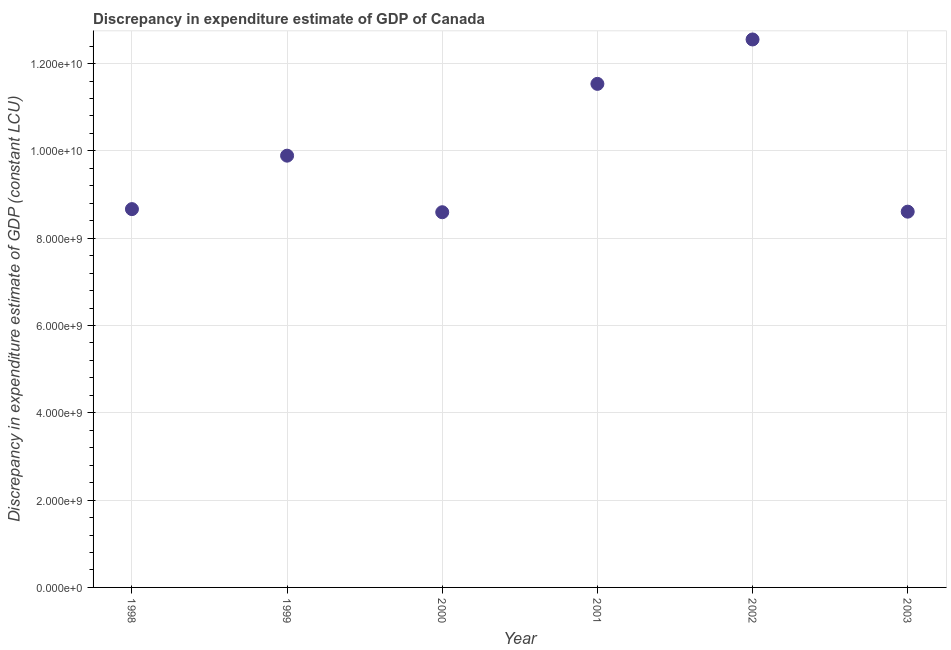What is the discrepancy in expenditure estimate of gdp in 2000?
Your response must be concise. 8.60e+09. Across all years, what is the maximum discrepancy in expenditure estimate of gdp?
Your response must be concise. 1.26e+1. Across all years, what is the minimum discrepancy in expenditure estimate of gdp?
Provide a short and direct response. 8.60e+09. In which year was the discrepancy in expenditure estimate of gdp minimum?
Your answer should be very brief. 2000. What is the sum of the discrepancy in expenditure estimate of gdp?
Your answer should be compact. 5.99e+1. What is the difference between the discrepancy in expenditure estimate of gdp in 1998 and 2002?
Offer a terse response. -3.89e+09. What is the average discrepancy in expenditure estimate of gdp per year?
Give a very brief answer. 9.98e+09. What is the median discrepancy in expenditure estimate of gdp?
Your answer should be compact. 9.28e+09. In how many years, is the discrepancy in expenditure estimate of gdp greater than 7600000000 LCU?
Your answer should be compact. 6. What is the ratio of the discrepancy in expenditure estimate of gdp in 1998 to that in 2002?
Your response must be concise. 0.69. Is the discrepancy in expenditure estimate of gdp in 1999 less than that in 2000?
Your answer should be compact. No. What is the difference between the highest and the second highest discrepancy in expenditure estimate of gdp?
Your answer should be compact. 1.02e+09. What is the difference between the highest and the lowest discrepancy in expenditure estimate of gdp?
Provide a succinct answer. 3.96e+09. In how many years, is the discrepancy in expenditure estimate of gdp greater than the average discrepancy in expenditure estimate of gdp taken over all years?
Keep it short and to the point. 2. Does the discrepancy in expenditure estimate of gdp monotonically increase over the years?
Offer a terse response. No. How many dotlines are there?
Make the answer very short. 1. How many years are there in the graph?
Provide a succinct answer. 6. What is the difference between two consecutive major ticks on the Y-axis?
Make the answer very short. 2.00e+09. What is the title of the graph?
Your response must be concise. Discrepancy in expenditure estimate of GDP of Canada. What is the label or title of the Y-axis?
Provide a short and direct response. Discrepancy in expenditure estimate of GDP (constant LCU). What is the Discrepancy in expenditure estimate of GDP (constant LCU) in 1998?
Give a very brief answer. 8.67e+09. What is the Discrepancy in expenditure estimate of GDP (constant LCU) in 1999?
Your answer should be compact. 9.89e+09. What is the Discrepancy in expenditure estimate of GDP (constant LCU) in 2000?
Provide a succinct answer. 8.60e+09. What is the Discrepancy in expenditure estimate of GDP (constant LCU) in 2001?
Provide a short and direct response. 1.15e+1. What is the Discrepancy in expenditure estimate of GDP (constant LCU) in 2002?
Offer a terse response. 1.26e+1. What is the Discrepancy in expenditure estimate of GDP (constant LCU) in 2003?
Make the answer very short. 8.61e+09. What is the difference between the Discrepancy in expenditure estimate of GDP (constant LCU) in 1998 and 1999?
Ensure brevity in your answer.  -1.22e+09. What is the difference between the Discrepancy in expenditure estimate of GDP (constant LCU) in 1998 and 2000?
Offer a terse response. 7.13e+07. What is the difference between the Discrepancy in expenditure estimate of GDP (constant LCU) in 1998 and 2001?
Ensure brevity in your answer.  -2.87e+09. What is the difference between the Discrepancy in expenditure estimate of GDP (constant LCU) in 1998 and 2002?
Provide a short and direct response. -3.89e+09. What is the difference between the Discrepancy in expenditure estimate of GDP (constant LCU) in 1998 and 2003?
Provide a succinct answer. 5.85e+07. What is the difference between the Discrepancy in expenditure estimate of GDP (constant LCU) in 1999 and 2000?
Your response must be concise. 1.30e+09. What is the difference between the Discrepancy in expenditure estimate of GDP (constant LCU) in 1999 and 2001?
Ensure brevity in your answer.  -1.64e+09. What is the difference between the Discrepancy in expenditure estimate of GDP (constant LCU) in 1999 and 2002?
Your response must be concise. -2.66e+09. What is the difference between the Discrepancy in expenditure estimate of GDP (constant LCU) in 1999 and 2003?
Give a very brief answer. 1.28e+09. What is the difference between the Discrepancy in expenditure estimate of GDP (constant LCU) in 2000 and 2001?
Make the answer very short. -2.94e+09. What is the difference between the Discrepancy in expenditure estimate of GDP (constant LCU) in 2000 and 2002?
Keep it short and to the point. -3.96e+09. What is the difference between the Discrepancy in expenditure estimate of GDP (constant LCU) in 2000 and 2003?
Your response must be concise. -1.29e+07. What is the difference between the Discrepancy in expenditure estimate of GDP (constant LCU) in 2001 and 2002?
Make the answer very short. -1.02e+09. What is the difference between the Discrepancy in expenditure estimate of GDP (constant LCU) in 2001 and 2003?
Your answer should be very brief. 2.93e+09. What is the difference between the Discrepancy in expenditure estimate of GDP (constant LCU) in 2002 and 2003?
Offer a terse response. 3.94e+09. What is the ratio of the Discrepancy in expenditure estimate of GDP (constant LCU) in 1998 to that in 1999?
Offer a very short reply. 0.88. What is the ratio of the Discrepancy in expenditure estimate of GDP (constant LCU) in 1998 to that in 2001?
Provide a short and direct response. 0.75. What is the ratio of the Discrepancy in expenditure estimate of GDP (constant LCU) in 1998 to that in 2002?
Your answer should be very brief. 0.69. What is the ratio of the Discrepancy in expenditure estimate of GDP (constant LCU) in 1999 to that in 2000?
Your response must be concise. 1.15. What is the ratio of the Discrepancy in expenditure estimate of GDP (constant LCU) in 1999 to that in 2001?
Provide a succinct answer. 0.86. What is the ratio of the Discrepancy in expenditure estimate of GDP (constant LCU) in 1999 to that in 2002?
Give a very brief answer. 0.79. What is the ratio of the Discrepancy in expenditure estimate of GDP (constant LCU) in 1999 to that in 2003?
Offer a terse response. 1.15. What is the ratio of the Discrepancy in expenditure estimate of GDP (constant LCU) in 2000 to that in 2001?
Offer a terse response. 0.74. What is the ratio of the Discrepancy in expenditure estimate of GDP (constant LCU) in 2000 to that in 2002?
Your answer should be compact. 0.69. What is the ratio of the Discrepancy in expenditure estimate of GDP (constant LCU) in 2000 to that in 2003?
Your response must be concise. 1. What is the ratio of the Discrepancy in expenditure estimate of GDP (constant LCU) in 2001 to that in 2002?
Your answer should be very brief. 0.92. What is the ratio of the Discrepancy in expenditure estimate of GDP (constant LCU) in 2001 to that in 2003?
Provide a short and direct response. 1.34. What is the ratio of the Discrepancy in expenditure estimate of GDP (constant LCU) in 2002 to that in 2003?
Provide a succinct answer. 1.46. 